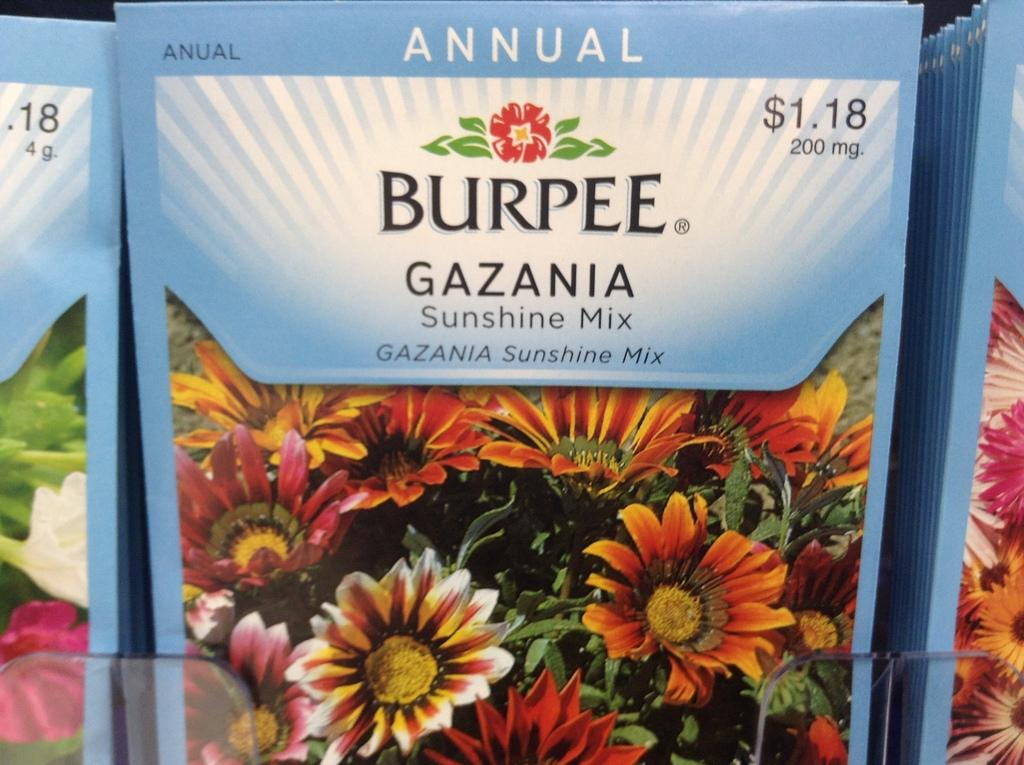What type of objects can be seen in the image? There are books in the image. What can be found on the books? The books have pictures and text. What specific images are depicted on the books? There are pictures of flowers on the books. Can you tell me how the books are used to support the magic in the image? There is no mention of magic or any magical elements in the image. The books are simply depicted with pictures and text, and there is no indication that they are used for any magical purposes. 